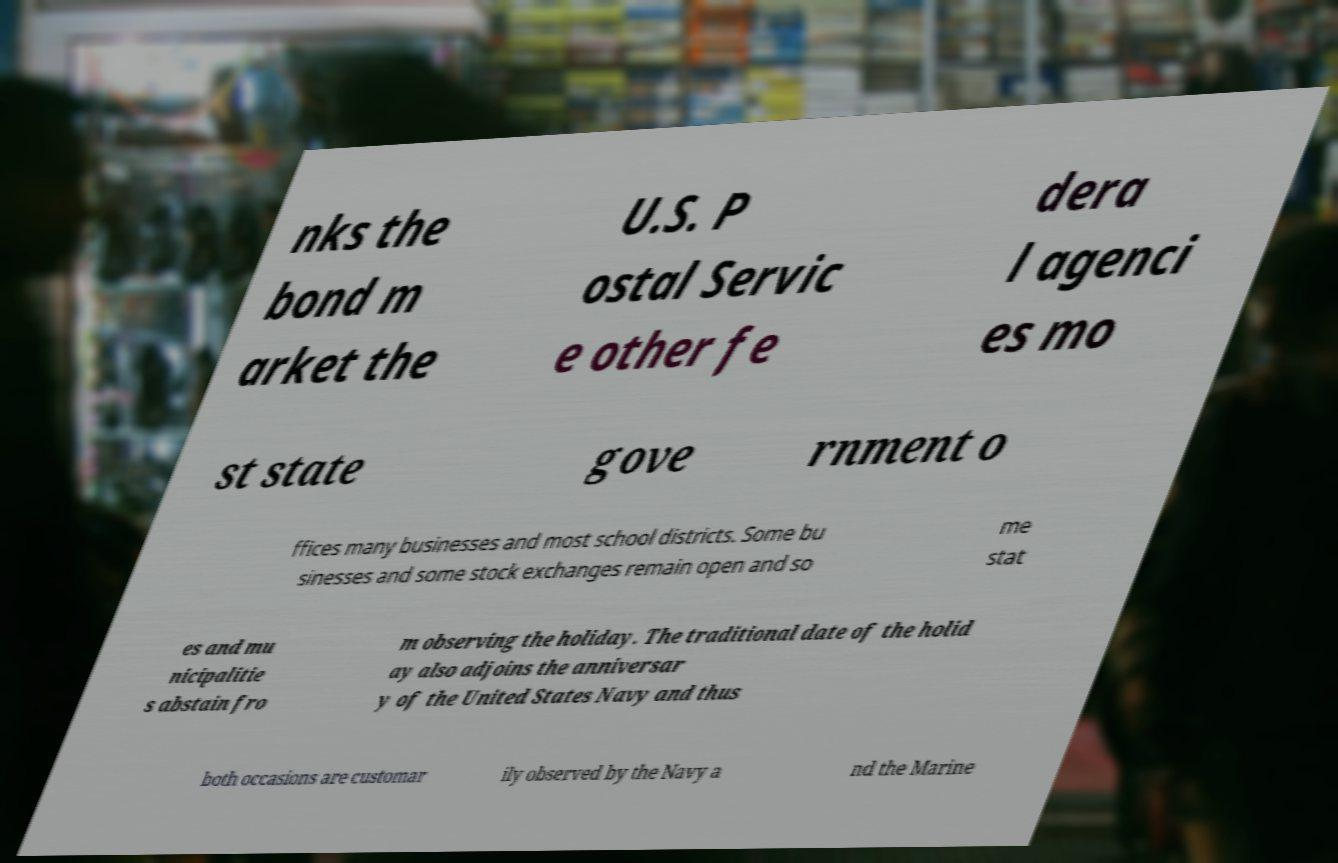Can you read and provide the text displayed in the image?This photo seems to have some interesting text. Can you extract and type it out for me? nks the bond m arket the U.S. P ostal Servic e other fe dera l agenci es mo st state gove rnment o ffices many businesses and most school districts. Some bu sinesses and some stock exchanges remain open and so me stat es and mu nicipalitie s abstain fro m observing the holiday. The traditional date of the holid ay also adjoins the anniversar y of the United States Navy and thus both occasions are customar ily observed by the Navy a nd the Marine 